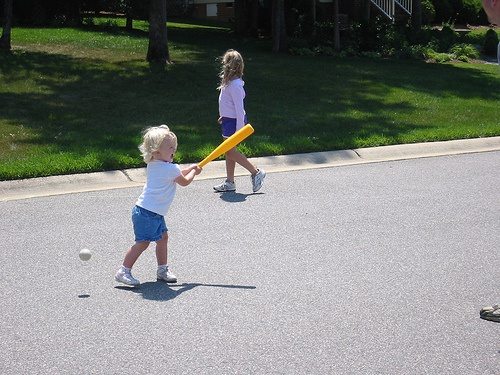Describe the objects in this image and their specific colors. I can see people in black, darkgray, gray, and blue tones, people in black, gray, darkgray, violet, and navy tones, baseball bat in black, orange, khaki, and olive tones, and sports ball in black, gray, white, and lightgray tones in this image. 